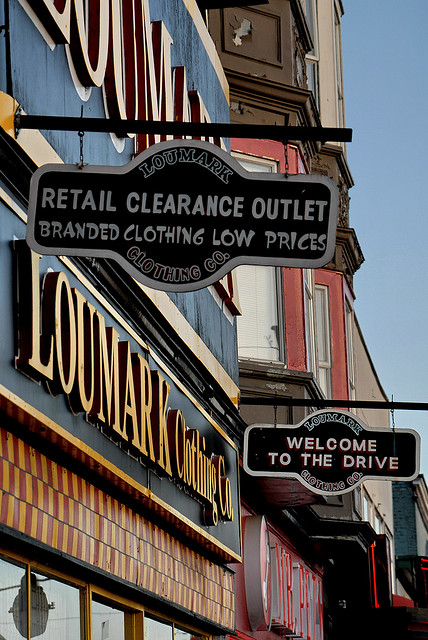Identify the text contained in this image. RETAIL CLEARANCE OUTLET LOUMARK BRANDED GO CLOTHING DRIVE THE TO LOUMARK WELOCME Clothing CO CLOTHING PRICES LOW CLOTHING 